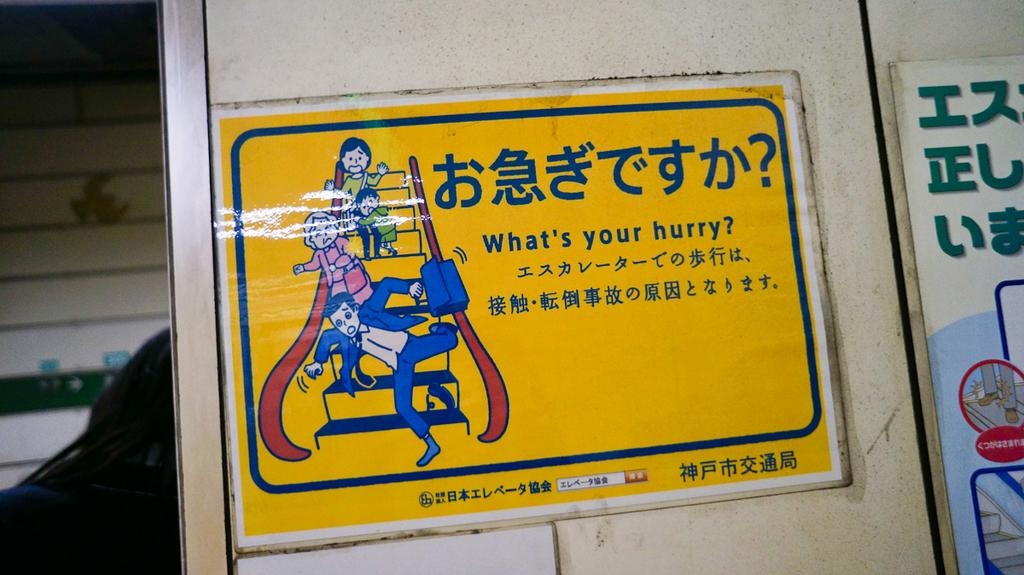<image>
Create a compact narrative representing the image presented. a sign that asks what the hurry is on a yellow background 